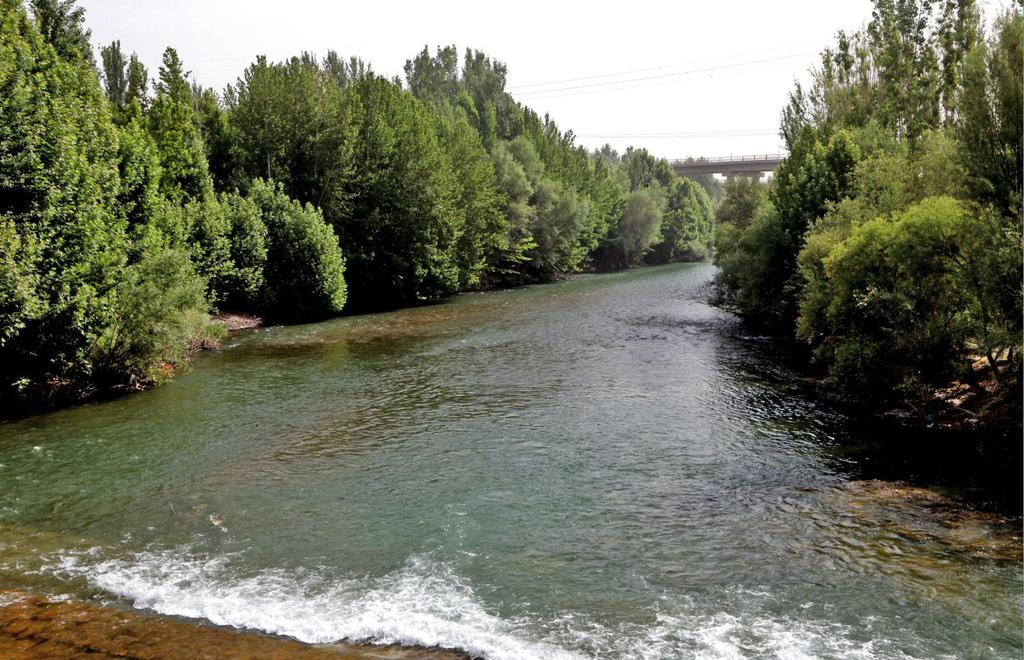What is the main feature in the center of the image? There is a river at the center of the image. What type of vegetation is present on either side of the river? There are trees on either side of the river. What can be seen in the background of the image? There is a bridge and the sky visible in the background of the image. How many dogs are playing with a scale in the image? There are no dogs or scales present in the image. 